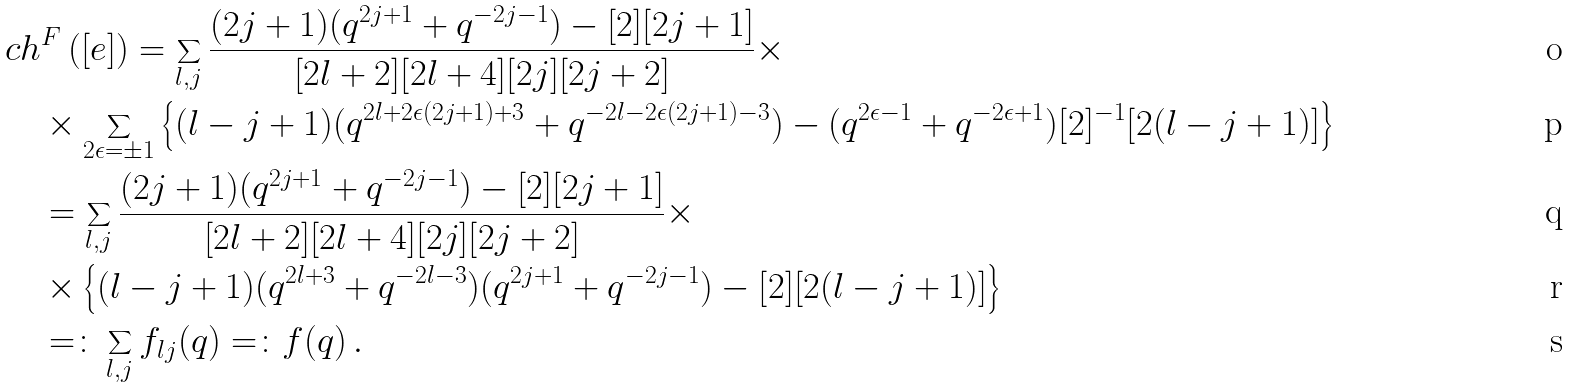<formula> <loc_0><loc_0><loc_500><loc_500>& c h ^ { F } \, ( [ e ] ) = \sum _ { l , j } \frac { ( 2 j + 1 ) ( q ^ { 2 j + 1 } + q ^ { - 2 j - 1 } ) - [ 2 ] [ 2 j + 1 ] } { [ 2 l + 2 ] [ 2 l + 4 ] [ 2 j ] [ 2 j + 2 ] } \times \\ & \quad \times \sum _ { 2 \epsilon = \pm 1 } \left \{ ( l - j + 1 ) ( q ^ { 2 l + 2 \epsilon ( 2 j + 1 ) + 3 } + q ^ { - 2 l - 2 \epsilon ( 2 j + 1 ) - 3 } ) - ( q ^ { 2 \epsilon - 1 } + q ^ { - 2 \epsilon + 1 } ) [ 2 ] ^ { - 1 } [ 2 ( l - j + 1 ) ] \right \} \\ & \quad = \sum _ { l , j } \frac { ( 2 j + 1 ) ( q ^ { 2 j + 1 } + q ^ { - 2 j - 1 } ) - [ 2 ] [ 2 j + 1 ] } { [ 2 l + 2 ] [ 2 l + 4 ] [ 2 j ] [ 2 j + 2 ] } \times \\ & \quad \times \left \{ ( l - j + 1 ) ( q ^ { 2 l + 3 } + q ^ { - 2 l - 3 } ) ( q ^ { 2 j + 1 } + q ^ { - 2 j - 1 } ) - [ 2 ] [ 2 ( l - j + 1 ) ] \right \} \\ & \quad = \colon \sum _ { l , j } f _ { l j } ( q ) = \colon f ( q ) \, .</formula> 